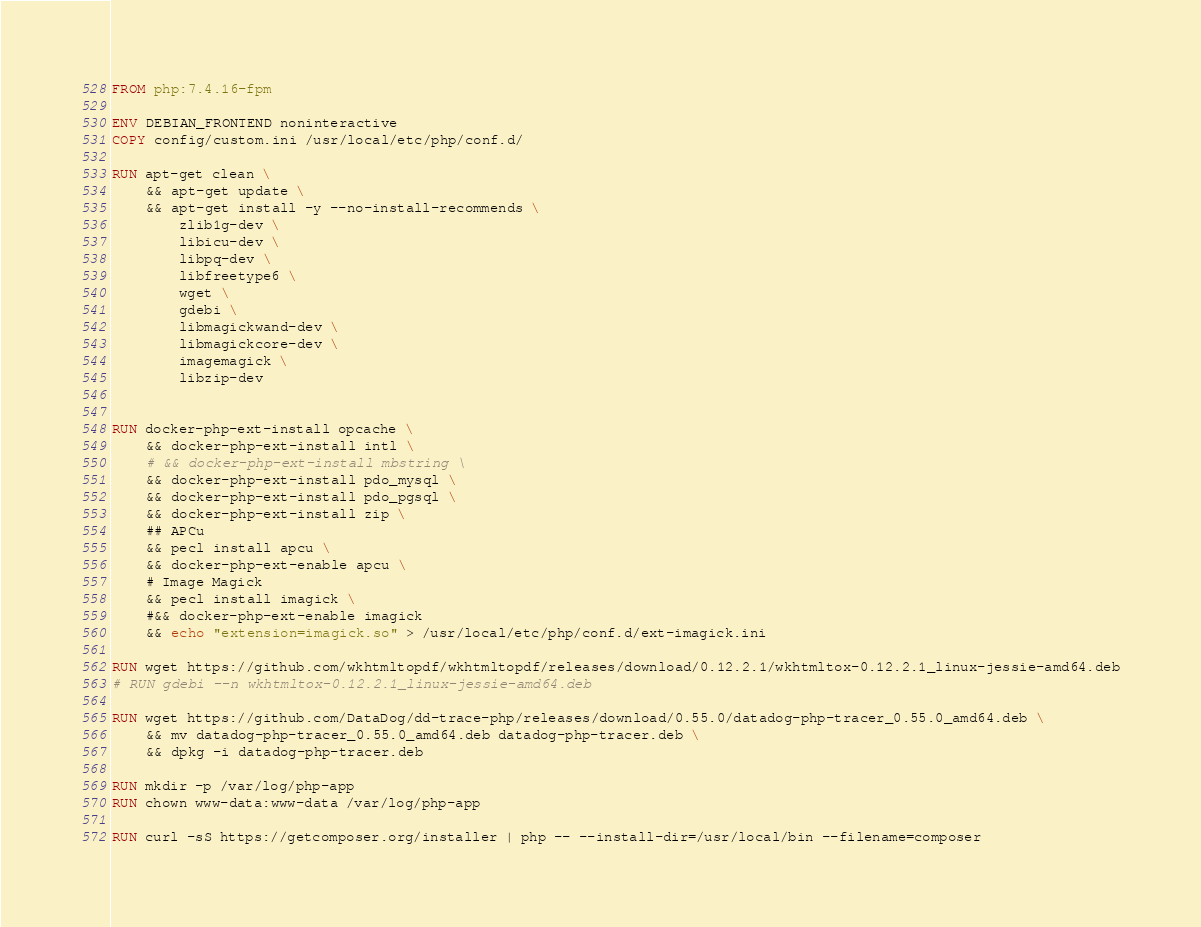Convert code to text. <code><loc_0><loc_0><loc_500><loc_500><_Dockerfile_>FROM php:7.4.16-fpm

ENV DEBIAN_FRONTEND noninteractive
COPY config/custom.ini /usr/local/etc/php/conf.d/

RUN apt-get clean \
    && apt-get update \
    && apt-get install -y --no-install-recommends \
        zlib1g-dev \
        libicu-dev \
        libpq-dev \
        libfreetype6 \
        wget \
        gdebi \
        libmagickwand-dev \
        libmagickcore-dev \
        imagemagick \
        libzip-dev


RUN docker-php-ext-install opcache \
    && docker-php-ext-install intl \
    # && docker-php-ext-install mbstring \
    && docker-php-ext-install pdo_mysql \
    && docker-php-ext-install pdo_pgsql \
    && docker-php-ext-install zip \
    ## APCu
    && pecl install apcu \
    && docker-php-ext-enable apcu \
    # Image Magick
    && pecl install imagick \
    #&& docker-php-ext-enable imagick
    && echo "extension=imagick.so" > /usr/local/etc/php/conf.d/ext-imagick.ini

RUN wget https://github.com/wkhtmltopdf/wkhtmltopdf/releases/download/0.12.2.1/wkhtmltox-0.12.2.1_linux-jessie-amd64.deb
# RUN gdebi --n wkhtmltox-0.12.2.1_linux-jessie-amd64.deb

RUN wget https://github.com/DataDog/dd-trace-php/releases/download/0.55.0/datadog-php-tracer_0.55.0_amd64.deb \
    && mv datadog-php-tracer_0.55.0_amd64.deb datadog-php-tracer.deb \
    && dpkg -i datadog-php-tracer.deb

RUN mkdir -p /var/log/php-app
RUN chown www-data:www-data /var/log/php-app

RUN curl -sS https://getcomposer.org/installer | php -- --install-dir=/usr/local/bin --filename=composer
</code> 